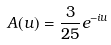<formula> <loc_0><loc_0><loc_500><loc_500>A ( u ) = \frac { 3 } { 2 5 } e ^ { - i u }</formula> 